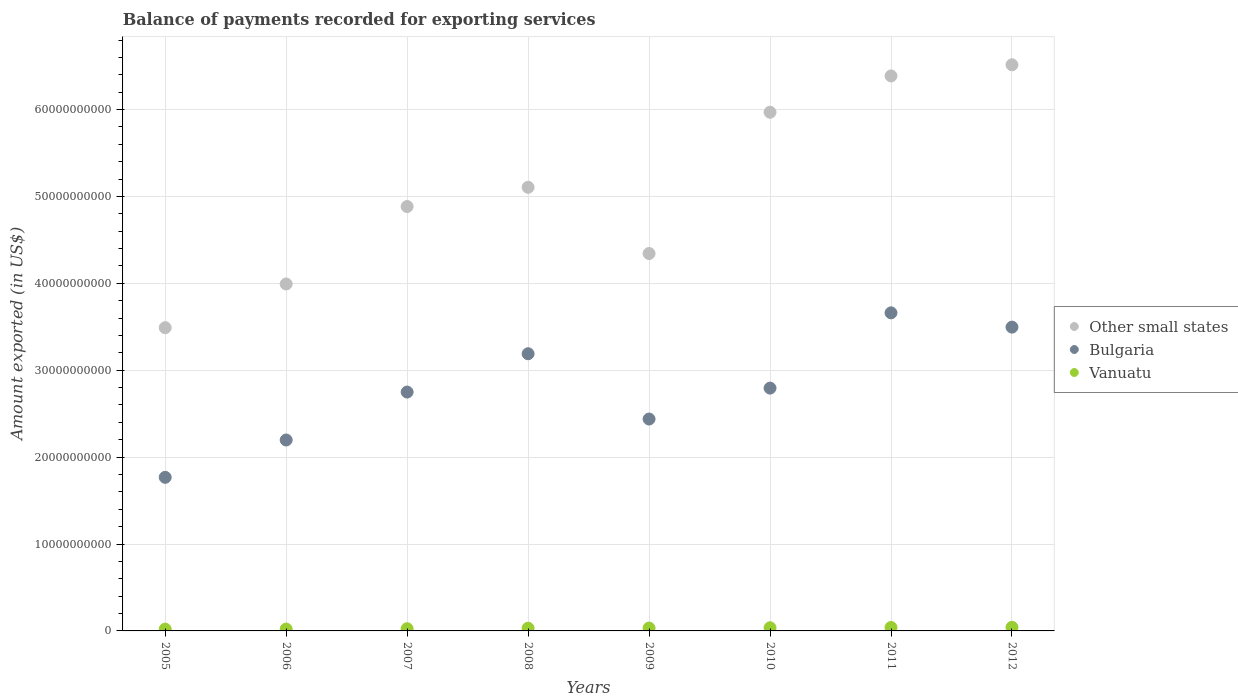How many different coloured dotlines are there?
Offer a terse response. 3. Is the number of dotlines equal to the number of legend labels?
Make the answer very short. Yes. What is the amount exported in Vanuatu in 2005?
Offer a terse response. 2.05e+08. Across all years, what is the maximum amount exported in Vanuatu?
Provide a succinct answer. 4.14e+08. Across all years, what is the minimum amount exported in Other small states?
Your answer should be compact. 3.49e+1. In which year was the amount exported in Other small states maximum?
Ensure brevity in your answer.  2012. What is the total amount exported in Vanuatu in the graph?
Ensure brevity in your answer.  2.50e+09. What is the difference between the amount exported in Other small states in 2007 and that in 2011?
Keep it short and to the point. -1.50e+1. What is the difference between the amount exported in Vanuatu in 2009 and the amount exported in Bulgaria in 2008?
Provide a short and direct response. -3.16e+1. What is the average amount exported in Other small states per year?
Provide a short and direct response. 5.09e+1. In the year 2009, what is the difference between the amount exported in Vanuatu and amount exported in Other small states?
Offer a very short reply. -4.31e+1. What is the ratio of the amount exported in Vanuatu in 2008 to that in 2011?
Ensure brevity in your answer.  0.79. Is the difference between the amount exported in Vanuatu in 2009 and 2011 greater than the difference between the amount exported in Other small states in 2009 and 2011?
Make the answer very short. Yes. What is the difference between the highest and the second highest amount exported in Bulgaria?
Ensure brevity in your answer.  1.65e+09. What is the difference between the highest and the lowest amount exported in Vanuatu?
Give a very brief answer. 2.09e+08. Is it the case that in every year, the sum of the amount exported in Vanuatu and amount exported in Other small states  is greater than the amount exported in Bulgaria?
Provide a short and direct response. Yes. Is the amount exported in Vanuatu strictly less than the amount exported in Other small states over the years?
Your answer should be compact. Yes. How many years are there in the graph?
Give a very brief answer. 8. Does the graph contain any zero values?
Offer a very short reply. No. Where does the legend appear in the graph?
Offer a very short reply. Center right. How many legend labels are there?
Your response must be concise. 3. What is the title of the graph?
Keep it short and to the point. Balance of payments recorded for exporting services. Does "Fiji" appear as one of the legend labels in the graph?
Your answer should be compact. No. What is the label or title of the X-axis?
Your answer should be very brief. Years. What is the label or title of the Y-axis?
Ensure brevity in your answer.  Amount exported (in US$). What is the Amount exported (in US$) in Other small states in 2005?
Keep it short and to the point. 3.49e+1. What is the Amount exported (in US$) of Bulgaria in 2005?
Provide a succinct answer. 1.77e+1. What is the Amount exported (in US$) in Vanuatu in 2005?
Provide a succinct answer. 2.05e+08. What is the Amount exported (in US$) of Other small states in 2006?
Provide a short and direct response. 3.99e+1. What is the Amount exported (in US$) in Bulgaria in 2006?
Keep it short and to the point. 2.20e+1. What is the Amount exported (in US$) in Vanuatu in 2006?
Give a very brief answer. 2.15e+08. What is the Amount exported (in US$) in Other small states in 2007?
Make the answer very short. 4.88e+1. What is the Amount exported (in US$) of Bulgaria in 2007?
Provide a succinct answer. 2.75e+1. What is the Amount exported (in US$) of Vanuatu in 2007?
Your response must be concise. 2.56e+08. What is the Amount exported (in US$) in Other small states in 2008?
Ensure brevity in your answer.  5.11e+1. What is the Amount exported (in US$) of Bulgaria in 2008?
Your answer should be very brief. 3.19e+1. What is the Amount exported (in US$) in Vanuatu in 2008?
Ensure brevity in your answer.  3.14e+08. What is the Amount exported (in US$) in Other small states in 2009?
Keep it short and to the point. 4.34e+1. What is the Amount exported (in US$) of Bulgaria in 2009?
Keep it short and to the point. 2.44e+1. What is the Amount exported (in US$) in Vanuatu in 2009?
Offer a very short reply. 3.31e+08. What is the Amount exported (in US$) in Other small states in 2010?
Offer a very short reply. 5.97e+1. What is the Amount exported (in US$) in Bulgaria in 2010?
Offer a terse response. 2.79e+1. What is the Amount exported (in US$) of Vanuatu in 2010?
Offer a terse response. 3.65e+08. What is the Amount exported (in US$) of Other small states in 2011?
Your response must be concise. 6.39e+1. What is the Amount exported (in US$) of Bulgaria in 2011?
Provide a short and direct response. 3.66e+1. What is the Amount exported (in US$) of Vanuatu in 2011?
Give a very brief answer. 3.96e+08. What is the Amount exported (in US$) of Other small states in 2012?
Provide a short and direct response. 6.52e+1. What is the Amount exported (in US$) of Bulgaria in 2012?
Ensure brevity in your answer.  3.50e+1. What is the Amount exported (in US$) in Vanuatu in 2012?
Offer a very short reply. 4.14e+08. Across all years, what is the maximum Amount exported (in US$) in Other small states?
Offer a terse response. 6.52e+1. Across all years, what is the maximum Amount exported (in US$) of Bulgaria?
Your response must be concise. 3.66e+1. Across all years, what is the maximum Amount exported (in US$) of Vanuatu?
Provide a succinct answer. 4.14e+08. Across all years, what is the minimum Amount exported (in US$) in Other small states?
Your response must be concise. 3.49e+1. Across all years, what is the minimum Amount exported (in US$) in Bulgaria?
Your answer should be compact. 1.77e+1. Across all years, what is the minimum Amount exported (in US$) in Vanuatu?
Give a very brief answer. 2.05e+08. What is the total Amount exported (in US$) of Other small states in the graph?
Offer a very short reply. 4.07e+11. What is the total Amount exported (in US$) in Bulgaria in the graph?
Your answer should be compact. 2.23e+11. What is the total Amount exported (in US$) in Vanuatu in the graph?
Keep it short and to the point. 2.50e+09. What is the difference between the Amount exported (in US$) in Other small states in 2005 and that in 2006?
Ensure brevity in your answer.  -5.03e+09. What is the difference between the Amount exported (in US$) of Bulgaria in 2005 and that in 2006?
Offer a terse response. -4.30e+09. What is the difference between the Amount exported (in US$) of Vanuatu in 2005 and that in 2006?
Give a very brief answer. -1.07e+07. What is the difference between the Amount exported (in US$) in Other small states in 2005 and that in 2007?
Make the answer very short. -1.39e+1. What is the difference between the Amount exported (in US$) of Bulgaria in 2005 and that in 2007?
Provide a short and direct response. -9.81e+09. What is the difference between the Amount exported (in US$) in Vanuatu in 2005 and that in 2007?
Keep it short and to the point. -5.11e+07. What is the difference between the Amount exported (in US$) of Other small states in 2005 and that in 2008?
Your answer should be compact. -1.62e+1. What is the difference between the Amount exported (in US$) in Bulgaria in 2005 and that in 2008?
Your response must be concise. -1.42e+1. What is the difference between the Amount exported (in US$) in Vanuatu in 2005 and that in 2008?
Your answer should be compact. -1.09e+08. What is the difference between the Amount exported (in US$) of Other small states in 2005 and that in 2009?
Your answer should be compact. -8.53e+09. What is the difference between the Amount exported (in US$) of Bulgaria in 2005 and that in 2009?
Provide a short and direct response. -6.71e+09. What is the difference between the Amount exported (in US$) of Vanuatu in 2005 and that in 2009?
Your response must be concise. -1.26e+08. What is the difference between the Amount exported (in US$) in Other small states in 2005 and that in 2010?
Your answer should be compact. -2.48e+1. What is the difference between the Amount exported (in US$) of Bulgaria in 2005 and that in 2010?
Make the answer very short. -1.03e+1. What is the difference between the Amount exported (in US$) in Vanuatu in 2005 and that in 2010?
Give a very brief answer. -1.61e+08. What is the difference between the Amount exported (in US$) of Other small states in 2005 and that in 2011?
Your answer should be very brief. -2.90e+1. What is the difference between the Amount exported (in US$) in Bulgaria in 2005 and that in 2011?
Give a very brief answer. -1.89e+1. What is the difference between the Amount exported (in US$) in Vanuatu in 2005 and that in 2011?
Provide a succinct answer. -1.91e+08. What is the difference between the Amount exported (in US$) of Other small states in 2005 and that in 2012?
Offer a terse response. -3.03e+1. What is the difference between the Amount exported (in US$) of Bulgaria in 2005 and that in 2012?
Provide a succinct answer. -1.73e+1. What is the difference between the Amount exported (in US$) of Vanuatu in 2005 and that in 2012?
Your response must be concise. -2.09e+08. What is the difference between the Amount exported (in US$) in Other small states in 2006 and that in 2007?
Make the answer very short. -8.91e+09. What is the difference between the Amount exported (in US$) in Bulgaria in 2006 and that in 2007?
Give a very brief answer. -5.52e+09. What is the difference between the Amount exported (in US$) in Vanuatu in 2006 and that in 2007?
Offer a very short reply. -4.04e+07. What is the difference between the Amount exported (in US$) in Other small states in 2006 and that in 2008?
Ensure brevity in your answer.  -1.11e+1. What is the difference between the Amount exported (in US$) of Bulgaria in 2006 and that in 2008?
Give a very brief answer. -9.92e+09. What is the difference between the Amount exported (in US$) in Vanuatu in 2006 and that in 2008?
Offer a terse response. -9.83e+07. What is the difference between the Amount exported (in US$) of Other small states in 2006 and that in 2009?
Your answer should be very brief. -3.51e+09. What is the difference between the Amount exported (in US$) in Bulgaria in 2006 and that in 2009?
Your answer should be compact. -2.41e+09. What is the difference between the Amount exported (in US$) of Vanuatu in 2006 and that in 2009?
Offer a very short reply. -1.16e+08. What is the difference between the Amount exported (in US$) in Other small states in 2006 and that in 2010?
Give a very brief answer. -1.98e+1. What is the difference between the Amount exported (in US$) in Bulgaria in 2006 and that in 2010?
Offer a very short reply. -5.97e+09. What is the difference between the Amount exported (in US$) of Vanuatu in 2006 and that in 2010?
Keep it short and to the point. -1.50e+08. What is the difference between the Amount exported (in US$) in Other small states in 2006 and that in 2011?
Your response must be concise. -2.39e+1. What is the difference between the Amount exported (in US$) in Bulgaria in 2006 and that in 2011?
Give a very brief answer. -1.46e+1. What is the difference between the Amount exported (in US$) in Vanuatu in 2006 and that in 2011?
Give a very brief answer. -1.80e+08. What is the difference between the Amount exported (in US$) in Other small states in 2006 and that in 2012?
Keep it short and to the point. -2.52e+1. What is the difference between the Amount exported (in US$) in Bulgaria in 2006 and that in 2012?
Offer a terse response. -1.30e+1. What is the difference between the Amount exported (in US$) in Vanuatu in 2006 and that in 2012?
Make the answer very short. -1.98e+08. What is the difference between the Amount exported (in US$) of Other small states in 2007 and that in 2008?
Provide a succinct answer. -2.21e+09. What is the difference between the Amount exported (in US$) of Bulgaria in 2007 and that in 2008?
Provide a succinct answer. -4.41e+09. What is the difference between the Amount exported (in US$) of Vanuatu in 2007 and that in 2008?
Keep it short and to the point. -5.79e+07. What is the difference between the Amount exported (in US$) of Other small states in 2007 and that in 2009?
Your response must be concise. 5.41e+09. What is the difference between the Amount exported (in US$) of Bulgaria in 2007 and that in 2009?
Make the answer very short. 3.10e+09. What is the difference between the Amount exported (in US$) of Vanuatu in 2007 and that in 2009?
Offer a very short reply. -7.52e+07. What is the difference between the Amount exported (in US$) of Other small states in 2007 and that in 2010?
Offer a terse response. -1.09e+1. What is the difference between the Amount exported (in US$) of Bulgaria in 2007 and that in 2010?
Give a very brief answer. -4.56e+08. What is the difference between the Amount exported (in US$) of Vanuatu in 2007 and that in 2010?
Your answer should be compact. -1.10e+08. What is the difference between the Amount exported (in US$) in Other small states in 2007 and that in 2011?
Your response must be concise. -1.50e+1. What is the difference between the Amount exported (in US$) of Bulgaria in 2007 and that in 2011?
Your answer should be compact. -9.12e+09. What is the difference between the Amount exported (in US$) in Vanuatu in 2007 and that in 2011?
Make the answer very short. -1.40e+08. What is the difference between the Amount exported (in US$) of Other small states in 2007 and that in 2012?
Your answer should be very brief. -1.63e+1. What is the difference between the Amount exported (in US$) of Bulgaria in 2007 and that in 2012?
Offer a very short reply. -7.47e+09. What is the difference between the Amount exported (in US$) of Vanuatu in 2007 and that in 2012?
Keep it short and to the point. -1.58e+08. What is the difference between the Amount exported (in US$) of Other small states in 2008 and that in 2009?
Your answer should be very brief. 7.62e+09. What is the difference between the Amount exported (in US$) of Bulgaria in 2008 and that in 2009?
Your response must be concise. 7.51e+09. What is the difference between the Amount exported (in US$) of Vanuatu in 2008 and that in 2009?
Your answer should be compact. -1.73e+07. What is the difference between the Amount exported (in US$) of Other small states in 2008 and that in 2010?
Provide a succinct answer. -8.64e+09. What is the difference between the Amount exported (in US$) in Bulgaria in 2008 and that in 2010?
Provide a short and direct response. 3.95e+09. What is the difference between the Amount exported (in US$) in Vanuatu in 2008 and that in 2010?
Give a very brief answer. -5.18e+07. What is the difference between the Amount exported (in US$) in Other small states in 2008 and that in 2011?
Your response must be concise. -1.28e+1. What is the difference between the Amount exported (in US$) in Bulgaria in 2008 and that in 2011?
Make the answer very short. -4.71e+09. What is the difference between the Amount exported (in US$) in Vanuatu in 2008 and that in 2011?
Provide a succinct answer. -8.20e+07. What is the difference between the Amount exported (in US$) of Other small states in 2008 and that in 2012?
Your response must be concise. -1.41e+1. What is the difference between the Amount exported (in US$) of Bulgaria in 2008 and that in 2012?
Your answer should be compact. -3.06e+09. What is the difference between the Amount exported (in US$) in Vanuatu in 2008 and that in 2012?
Offer a very short reply. -1.00e+08. What is the difference between the Amount exported (in US$) in Other small states in 2009 and that in 2010?
Keep it short and to the point. -1.63e+1. What is the difference between the Amount exported (in US$) in Bulgaria in 2009 and that in 2010?
Ensure brevity in your answer.  -3.56e+09. What is the difference between the Amount exported (in US$) in Vanuatu in 2009 and that in 2010?
Provide a succinct answer. -3.45e+07. What is the difference between the Amount exported (in US$) of Other small states in 2009 and that in 2011?
Offer a very short reply. -2.04e+1. What is the difference between the Amount exported (in US$) of Bulgaria in 2009 and that in 2011?
Your answer should be very brief. -1.22e+1. What is the difference between the Amount exported (in US$) in Vanuatu in 2009 and that in 2011?
Your response must be concise. -6.48e+07. What is the difference between the Amount exported (in US$) in Other small states in 2009 and that in 2012?
Provide a short and direct response. -2.17e+1. What is the difference between the Amount exported (in US$) of Bulgaria in 2009 and that in 2012?
Provide a succinct answer. -1.06e+1. What is the difference between the Amount exported (in US$) of Vanuatu in 2009 and that in 2012?
Keep it short and to the point. -8.28e+07. What is the difference between the Amount exported (in US$) of Other small states in 2010 and that in 2011?
Your response must be concise. -4.18e+09. What is the difference between the Amount exported (in US$) of Bulgaria in 2010 and that in 2011?
Offer a very short reply. -8.66e+09. What is the difference between the Amount exported (in US$) in Vanuatu in 2010 and that in 2011?
Offer a very short reply. -3.03e+07. What is the difference between the Amount exported (in US$) in Other small states in 2010 and that in 2012?
Provide a succinct answer. -5.46e+09. What is the difference between the Amount exported (in US$) of Bulgaria in 2010 and that in 2012?
Offer a very short reply. -7.02e+09. What is the difference between the Amount exported (in US$) in Vanuatu in 2010 and that in 2012?
Ensure brevity in your answer.  -4.83e+07. What is the difference between the Amount exported (in US$) of Other small states in 2011 and that in 2012?
Your answer should be very brief. -1.28e+09. What is the difference between the Amount exported (in US$) in Bulgaria in 2011 and that in 2012?
Provide a short and direct response. 1.65e+09. What is the difference between the Amount exported (in US$) of Vanuatu in 2011 and that in 2012?
Offer a very short reply. -1.80e+07. What is the difference between the Amount exported (in US$) in Other small states in 2005 and the Amount exported (in US$) in Bulgaria in 2006?
Your answer should be compact. 1.29e+1. What is the difference between the Amount exported (in US$) of Other small states in 2005 and the Amount exported (in US$) of Vanuatu in 2006?
Provide a succinct answer. 3.47e+1. What is the difference between the Amount exported (in US$) in Bulgaria in 2005 and the Amount exported (in US$) in Vanuatu in 2006?
Make the answer very short. 1.75e+1. What is the difference between the Amount exported (in US$) in Other small states in 2005 and the Amount exported (in US$) in Bulgaria in 2007?
Your response must be concise. 7.41e+09. What is the difference between the Amount exported (in US$) of Other small states in 2005 and the Amount exported (in US$) of Vanuatu in 2007?
Offer a terse response. 3.46e+1. What is the difference between the Amount exported (in US$) in Bulgaria in 2005 and the Amount exported (in US$) in Vanuatu in 2007?
Ensure brevity in your answer.  1.74e+1. What is the difference between the Amount exported (in US$) of Other small states in 2005 and the Amount exported (in US$) of Bulgaria in 2008?
Ensure brevity in your answer.  3.00e+09. What is the difference between the Amount exported (in US$) of Other small states in 2005 and the Amount exported (in US$) of Vanuatu in 2008?
Make the answer very short. 3.46e+1. What is the difference between the Amount exported (in US$) in Bulgaria in 2005 and the Amount exported (in US$) in Vanuatu in 2008?
Your response must be concise. 1.74e+1. What is the difference between the Amount exported (in US$) of Other small states in 2005 and the Amount exported (in US$) of Bulgaria in 2009?
Give a very brief answer. 1.05e+1. What is the difference between the Amount exported (in US$) in Other small states in 2005 and the Amount exported (in US$) in Vanuatu in 2009?
Give a very brief answer. 3.46e+1. What is the difference between the Amount exported (in US$) in Bulgaria in 2005 and the Amount exported (in US$) in Vanuatu in 2009?
Give a very brief answer. 1.73e+1. What is the difference between the Amount exported (in US$) in Other small states in 2005 and the Amount exported (in US$) in Bulgaria in 2010?
Make the answer very short. 6.95e+09. What is the difference between the Amount exported (in US$) of Other small states in 2005 and the Amount exported (in US$) of Vanuatu in 2010?
Provide a succinct answer. 3.45e+1. What is the difference between the Amount exported (in US$) in Bulgaria in 2005 and the Amount exported (in US$) in Vanuatu in 2010?
Provide a succinct answer. 1.73e+1. What is the difference between the Amount exported (in US$) in Other small states in 2005 and the Amount exported (in US$) in Bulgaria in 2011?
Keep it short and to the point. -1.71e+09. What is the difference between the Amount exported (in US$) in Other small states in 2005 and the Amount exported (in US$) in Vanuatu in 2011?
Provide a succinct answer. 3.45e+1. What is the difference between the Amount exported (in US$) in Bulgaria in 2005 and the Amount exported (in US$) in Vanuatu in 2011?
Offer a terse response. 1.73e+1. What is the difference between the Amount exported (in US$) of Other small states in 2005 and the Amount exported (in US$) of Bulgaria in 2012?
Your answer should be compact. -6.24e+07. What is the difference between the Amount exported (in US$) of Other small states in 2005 and the Amount exported (in US$) of Vanuatu in 2012?
Give a very brief answer. 3.45e+1. What is the difference between the Amount exported (in US$) in Bulgaria in 2005 and the Amount exported (in US$) in Vanuatu in 2012?
Your response must be concise. 1.73e+1. What is the difference between the Amount exported (in US$) in Other small states in 2006 and the Amount exported (in US$) in Bulgaria in 2007?
Your response must be concise. 1.24e+1. What is the difference between the Amount exported (in US$) in Other small states in 2006 and the Amount exported (in US$) in Vanuatu in 2007?
Make the answer very short. 3.97e+1. What is the difference between the Amount exported (in US$) in Bulgaria in 2006 and the Amount exported (in US$) in Vanuatu in 2007?
Provide a succinct answer. 2.17e+1. What is the difference between the Amount exported (in US$) of Other small states in 2006 and the Amount exported (in US$) of Bulgaria in 2008?
Provide a succinct answer. 8.03e+09. What is the difference between the Amount exported (in US$) in Other small states in 2006 and the Amount exported (in US$) in Vanuatu in 2008?
Keep it short and to the point. 3.96e+1. What is the difference between the Amount exported (in US$) in Bulgaria in 2006 and the Amount exported (in US$) in Vanuatu in 2008?
Keep it short and to the point. 2.17e+1. What is the difference between the Amount exported (in US$) in Other small states in 2006 and the Amount exported (in US$) in Bulgaria in 2009?
Give a very brief answer. 1.55e+1. What is the difference between the Amount exported (in US$) of Other small states in 2006 and the Amount exported (in US$) of Vanuatu in 2009?
Provide a short and direct response. 3.96e+1. What is the difference between the Amount exported (in US$) of Bulgaria in 2006 and the Amount exported (in US$) of Vanuatu in 2009?
Offer a very short reply. 2.16e+1. What is the difference between the Amount exported (in US$) in Other small states in 2006 and the Amount exported (in US$) in Bulgaria in 2010?
Make the answer very short. 1.20e+1. What is the difference between the Amount exported (in US$) of Other small states in 2006 and the Amount exported (in US$) of Vanuatu in 2010?
Keep it short and to the point. 3.96e+1. What is the difference between the Amount exported (in US$) in Bulgaria in 2006 and the Amount exported (in US$) in Vanuatu in 2010?
Provide a succinct answer. 2.16e+1. What is the difference between the Amount exported (in US$) of Other small states in 2006 and the Amount exported (in US$) of Bulgaria in 2011?
Give a very brief answer. 3.32e+09. What is the difference between the Amount exported (in US$) in Other small states in 2006 and the Amount exported (in US$) in Vanuatu in 2011?
Offer a terse response. 3.95e+1. What is the difference between the Amount exported (in US$) of Bulgaria in 2006 and the Amount exported (in US$) of Vanuatu in 2011?
Offer a very short reply. 2.16e+1. What is the difference between the Amount exported (in US$) of Other small states in 2006 and the Amount exported (in US$) of Bulgaria in 2012?
Give a very brief answer. 4.97e+09. What is the difference between the Amount exported (in US$) in Other small states in 2006 and the Amount exported (in US$) in Vanuatu in 2012?
Give a very brief answer. 3.95e+1. What is the difference between the Amount exported (in US$) in Bulgaria in 2006 and the Amount exported (in US$) in Vanuatu in 2012?
Provide a short and direct response. 2.16e+1. What is the difference between the Amount exported (in US$) of Other small states in 2007 and the Amount exported (in US$) of Bulgaria in 2008?
Your answer should be very brief. 1.69e+1. What is the difference between the Amount exported (in US$) in Other small states in 2007 and the Amount exported (in US$) in Vanuatu in 2008?
Your response must be concise. 4.85e+1. What is the difference between the Amount exported (in US$) in Bulgaria in 2007 and the Amount exported (in US$) in Vanuatu in 2008?
Your answer should be very brief. 2.72e+1. What is the difference between the Amount exported (in US$) in Other small states in 2007 and the Amount exported (in US$) in Bulgaria in 2009?
Provide a short and direct response. 2.45e+1. What is the difference between the Amount exported (in US$) of Other small states in 2007 and the Amount exported (in US$) of Vanuatu in 2009?
Your answer should be very brief. 4.85e+1. What is the difference between the Amount exported (in US$) in Bulgaria in 2007 and the Amount exported (in US$) in Vanuatu in 2009?
Give a very brief answer. 2.72e+1. What is the difference between the Amount exported (in US$) of Other small states in 2007 and the Amount exported (in US$) of Bulgaria in 2010?
Make the answer very short. 2.09e+1. What is the difference between the Amount exported (in US$) in Other small states in 2007 and the Amount exported (in US$) in Vanuatu in 2010?
Provide a succinct answer. 4.85e+1. What is the difference between the Amount exported (in US$) of Bulgaria in 2007 and the Amount exported (in US$) of Vanuatu in 2010?
Offer a terse response. 2.71e+1. What is the difference between the Amount exported (in US$) of Other small states in 2007 and the Amount exported (in US$) of Bulgaria in 2011?
Your answer should be very brief. 1.22e+1. What is the difference between the Amount exported (in US$) in Other small states in 2007 and the Amount exported (in US$) in Vanuatu in 2011?
Keep it short and to the point. 4.84e+1. What is the difference between the Amount exported (in US$) of Bulgaria in 2007 and the Amount exported (in US$) of Vanuatu in 2011?
Provide a short and direct response. 2.71e+1. What is the difference between the Amount exported (in US$) of Other small states in 2007 and the Amount exported (in US$) of Bulgaria in 2012?
Make the answer very short. 1.39e+1. What is the difference between the Amount exported (in US$) in Other small states in 2007 and the Amount exported (in US$) in Vanuatu in 2012?
Offer a very short reply. 4.84e+1. What is the difference between the Amount exported (in US$) of Bulgaria in 2007 and the Amount exported (in US$) of Vanuatu in 2012?
Provide a short and direct response. 2.71e+1. What is the difference between the Amount exported (in US$) of Other small states in 2008 and the Amount exported (in US$) of Bulgaria in 2009?
Your answer should be very brief. 2.67e+1. What is the difference between the Amount exported (in US$) in Other small states in 2008 and the Amount exported (in US$) in Vanuatu in 2009?
Offer a terse response. 5.07e+1. What is the difference between the Amount exported (in US$) of Bulgaria in 2008 and the Amount exported (in US$) of Vanuatu in 2009?
Your response must be concise. 3.16e+1. What is the difference between the Amount exported (in US$) of Other small states in 2008 and the Amount exported (in US$) of Bulgaria in 2010?
Your answer should be compact. 2.31e+1. What is the difference between the Amount exported (in US$) of Other small states in 2008 and the Amount exported (in US$) of Vanuatu in 2010?
Offer a terse response. 5.07e+1. What is the difference between the Amount exported (in US$) in Bulgaria in 2008 and the Amount exported (in US$) in Vanuatu in 2010?
Make the answer very short. 3.15e+1. What is the difference between the Amount exported (in US$) of Other small states in 2008 and the Amount exported (in US$) of Bulgaria in 2011?
Your answer should be compact. 1.44e+1. What is the difference between the Amount exported (in US$) of Other small states in 2008 and the Amount exported (in US$) of Vanuatu in 2011?
Keep it short and to the point. 5.07e+1. What is the difference between the Amount exported (in US$) in Bulgaria in 2008 and the Amount exported (in US$) in Vanuatu in 2011?
Give a very brief answer. 3.15e+1. What is the difference between the Amount exported (in US$) of Other small states in 2008 and the Amount exported (in US$) of Bulgaria in 2012?
Offer a terse response. 1.61e+1. What is the difference between the Amount exported (in US$) in Other small states in 2008 and the Amount exported (in US$) in Vanuatu in 2012?
Ensure brevity in your answer.  5.06e+1. What is the difference between the Amount exported (in US$) of Bulgaria in 2008 and the Amount exported (in US$) of Vanuatu in 2012?
Ensure brevity in your answer.  3.15e+1. What is the difference between the Amount exported (in US$) in Other small states in 2009 and the Amount exported (in US$) in Bulgaria in 2010?
Make the answer very short. 1.55e+1. What is the difference between the Amount exported (in US$) in Other small states in 2009 and the Amount exported (in US$) in Vanuatu in 2010?
Offer a very short reply. 4.31e+1. What is the difference between the Amount exported (in US$) of Bulgaria in 2009 and the Amount exported (in US$) of Vanuatu in 2010?
Keep it short and to the point. 2.40e+1. What is the difference between the Amount exported (in US$) of Other small states in 2009 and the Amount exported (in US$) of Bulgaria in 2011?
Provide a short and direct response. 6.83e+09. What is the difference between the Amount exported (in US$) in Other small states in 2009 and the Amount exported (in US$) in Vanuatu in 2011?
Ensure brevity in your answer.  4.30e+1. What is the difference between the Amount exported (in US$) in Bulgaria in 2009 and the Amount exported (in US$) in Vanuatu in 2011?
Make the answer very short. 2.40e+1. What is the difference between the Amount exported (in US$) in Other small states in 2009 and the Amount exported (in US$) in Bulgaria in 2012?
Make the answer very short. 8.47e+09. What is the difference between the Amount exported (in US$) of Other small states in 2009 and the Amount exported (in US$) of Vanuatu in 2012?
Offer a very short reply. 4.30e+1. What is the difference between the Amount exported (in US$) of Bulgaria in 2009 and the Amount exported (in US$) of Vanuatu in 2012?
Provide a short and direct response. 2.40e+1. What is the difference between the Amount exported (in US$) in Other small states in 2010 and the Amount exported (in US$) in Bulgaria in 2011?
Make the answer very short. 2.31e+1. What is the difference between the Amount exported (in US$) in Other small states in 2010 and the Amount exported (in US$) in Vanuatu in 2011?
Keep it short and to the point. 5.93e+1. What is the difference between the Amount exported (in US$) in Bulgaria in 2010 and the Amount exported (in US$) in Vanuatu in 2011?
Ensure brevity in your answer.  2.75e+1. What is the difference between the Amount exported (in US$) in Other small states in 2010 and the Amount exported (in US$) in Bulgaria in 2012?
Make the answer very short. 2.47e+1. What is the difference between the Amount exported (in US$) in Other small states in 2010 and the Amount exported (in US$) in Vanuatu in 2012?
Offer a terse response. 5.93e+1. What is the difference between the Amount exported (in US$) in Bulgaria in 2010 and the Amount exported (in US$) in Vanuatu in 2012?
Provide a succinct answer. 2.75e+1. What is the difference between the Amount exported (in US$) in Other small states in 2011 and the Amount exported (in US$) in Bulgaria in 2012?
Keep it short and to the point. 2.89e+1. What is the difference between the Amount exported (in US$) of Other small states in 2011 and the Amount exported (in US$) of Vanuatu in 2012?
Make the answer very short. 6.35e+1. What is the difference between the Amount exported (in US$) of Bulgaria in 2011 and the Amount exported (in US$) of Vanuatu in 2012?
Provide a short and direct response. 3.62e+1. What is the average Amount exported (in US$) in Other small states per year?
Make the answer very short. 5.09e+1. What is the average Amount exported (in US$) in Bulgaria per year?
Your answer should be compact. 2.79e+1. What is the average Amount exported (in US$) in Vanuatu per year?
Offer a very short reply. 3.12e+08. In the year 2005, what is the difference between the Amount exported (in US$) of Other small states and Amount exported (in US$) of Bulgaria?
Give a very brief answer. 1.72e+1. In the year 2005, what is the difference between the Amount exported (in US$) in Other small states and Amount exported (in US$) in Vanuatu?
Keep it short and to the point. 3.47e+1. In the year 2005, what is the difference between the Amount exported (in US$) of Bulgaria and Amount exported (in US$) of Vanuatu?
Your answer should be very brief. 1.75e+1. In the year 2006, what is the difference between the Amount exported (in US$) of Other small states and Amount exported (in US$) of Bulgaria?
Keep it short and to the point. 1.80e+1. In the year 2006, what is the difference between the Amount exported (in US$) in Other small states and Amount exported (in US$) in Vanuatu?
Make the answer very short. 3.97e+1. In the year 2006, what is the difference between the Amount exported (in US$) in Bulgaria and Amount exported (in US$) in Vanuatu?
Provide a short and direct response. 2.18e+1. In the year 2007, what is the difference between the Amount exported (in US$) in Other small states and Amount exported (in US$) in Bulgaria?
Provide a succinct answer. 2.14e+1. In the year 2007, what is the difference between the Amount exported (in US$) of Other small states and Amount exported (in US$) of Vanuatu?
Give a very brief answer. 4.86e+1. In the year 2007, what is the difference between the Amount exported (in US$) of Bulgaria and Amount exported (in US$) of Vanuatu?
Ensure brevity in your answer.  2.72e+1. In the year 2008, what is the difference between the Amount exported (in US$) of Other small states and Amount exported (in US$) of Bulgaria?
Provide a succinct answer. 1.92e+1. In the year 2008, what is the difference between the Amount exported (in US$) in Other small states and Amount exported (in US$) in Vanuatu?
Your answer should be very brief. 5.07e+1. In the year 2008, what is the difference between the Amount exported (in US$) in Bulgaria and Amount exported (in US$) in Vanuatu?
Provide a short and direct response. 3.16e+1. In the year 2009, what is the difference between the Amount exported (in US$) of Other small states and Amount exported (in US$) of Bulgaria?
Offer a terse response. 1.90e+1. In the year 2009, what is the difference between the Amount exported (in US$) in Other small states and Amount exported (in US$) in Vanuatu?
Your answer should be compact. 4.31e+1. In the year 2009, what is the difference between the Amount exported (in US$) of Bulgaria and Amount exported (in US$) of Vanuatu?
Offer a terse response. 2.41e+1. In the year 2010, what is the difference between the Amount exported (in US$) of Other small states and Amount exported (in US$) of Bulgaria?
Offer a terse response. 3.17e+1. In the year 2010, what is the difference between the Amount exported (in US$) of Other small states and Amount exported (in US$) of Vanuatu?
Offer a very short reply. 5.93e+1. In the year 2010, what is the difference between the Amount exported (in US$) of Bulgaria and Amount exported (in US$) of Vanuatu?
Your response must be concise. 2.76e+1. In the year 2011, what is the difference between the Amount exported (in US$) of Other small states and Amount exported (in US$) of Bulgaria?
Offer a very short reply. 2.73e+1. In the year 2011, what is the difference between the Amount exported (in US$) of Other small states and Amount exported (in US$) of Vanuatu?
Provide a succinct answer. 6.35e+1. In the year 2011, what is the difference between the Amount exported (in US$) in Bulgaria and Amount exported (in US$) in Vanuatu?
Your answer should be very brief. 3.62e+1. In the year 2012, what is the difference between the Amount exported (in US$) in Other small states and Amount exported (in US$) in Bulgaria?
Offer a very short reply. 3.02e+1. In the year 2012, what is the difference between the Amount exported (in US$) in Other small states and Amount exported (in US$) in Vanuatu?
Keep it short and to the point. 6.47e+1. In the year 2012, what is the difference between the Amount exported (in US$) of Bulgaria and Amount exported (in US$) of Vanuatu?
Give a very brief answer. 3.45e+1. What is the ratio of the Amount exported (in US$) in Other small states in 2005 to that in 2006?
Keep it short and to the point. 0.87. What is the ratio of the Amount exported (in US$) in Bulgaria in 2005 to that in 2006?
Give a very brief answer. 0.8. What is the ratio of the Amount exported (in US$) in Vanuatu in 2005 to that in 2006?
Offer a terse response. 0.95. What is the ratio of the Amount exported (in US$) in Other small states in 2005 to that in 2007?
Your answer should be very brief. 0.71. What is the ratio of the Amount exported (in US$) of Bulgaria in 2005 to that in 2007?
Your answer should be very brief. 0.64. What is the ratio of the Amount exported (in US$) in Other small states in 2005 to that in 2008?
Provide a succinct answer. 0.68. What is the ratio of the Amount exported (in US$) of Bulgaria in 2005 to that in 2008?
Provide a short and direct response. 0.55. What is the ratio of the Amount exported (in US$) in Vanuatu in 2005 to that in 2008?
Your response must be concise. 0.65. What is the ratio of the Amount exported (in US$) of Other small states in 2005 to that in 2009?
Provide a succinct answer. 0.8. What is the ratio of the Amount exported (in US$) in Bulgaria in 2005 to that in 2009?
Provide a short and direct response. 0.72. What is the ratio of the Amount exported (in US$) of Vanuatu in 2005 to that in 2009?
Provide a short and direct response. 0.62. What is the ratio of the Amount exported (in US$) in Other small states in 2005 to that in 2010?
Offer a terse response. 0.58. What is the ratio of the Amount exported (in US$) in Bulgaria in 2005 to that in 2010?
Keep it short and to the point. 0.63. What is the ratio of the Amount exported (in US$) in Vanuatu in 2005 to that in 2010?
Provide a short and direct response. 0.56. What is the ratio of the Amount exported (in US$) of Other small states in 2005 to that in 2011?
Your answer should be very brief. 0.55. What is the ratio of the Amount exported (in US$) in Bulgaria in 2005 to that in 2011?
Give a very brief answer. 0.48. What is the ratio of the Amount exported (in US$) of Vanuatu in 2005 to that in 2011?
Your response must be concise. 0.52. What is the ratio of the Amount exported (in US$) of Other small states in 2005 to that in 2012?
Offer a very short reply. 0.54. What is the ratio of the Amount exported (in US$) of Bulgaria in 2005 to that in 2012?
Provide a succinct answer. 0.51. What is the ratio of the Amount exported (in US$) of Vanuatu in 2005 to that in 2012?
Make the answer very short. 0.49. What is the ratio of the Amount exported (in US$) in Other small states in 2006 to that in 2007?
Keep it short and to the point. 0.82. What is the ratio of the Amount exported (in US$) in Bulgaria in 2006 to that in 2007?
Your answer should be very brief. 0.8. What is the ratio of the Amount exported (in US$) of Vanuatu in 2006 to that in 2007?
Keep it short and to the point. 0.84. What is the ratio of the Amount exported (in US$) of Other small states in 2006 to that in 2008?
Your answer should be very brief. 0.78. What is the ratio of the Amount exported (in US$) of Bulgaria in 2006 to that in 2008?
Offer a very short reply. 0.69. What is the ratio of the Amount exported (in US$) of Vanuatu in 2006 to that in 2008?
Offer a very short reply. 0.69. What is the ratio of the Amount exported (in US$) of Other small states in 2006 to that in 2009?
Your answer should be very brief. 0.92. What is the ratio of the Amount exported (in US$) in Bulgaria in 2006 to that in 2009?
Make the answer very short. 0.9. What is the ratio of the Amount exported (in US$) in Vanuatu in 2006 to that in 2009?
Provide a succinct answer. 0.65. What is the ratio of the Amount exported (in US$) in Other small states in 2006 to that in 2010?
Offer a terse response. 0.67. What is the ratio of the Amount exported (in US$) in Bulgaria in 2006 to that in 2010?
Keep it short and to the point. 0.79. What is the ratio of the Amount exported (in US$) of Vanuatu in 2006 to that in 2010?
Keep it short and to the point. 0.59. What is the ratio of the Amount exported (in US$) of Other small states in 2006 to that in 2011?
Keep it short and to the point. 0.63. What is the ratio of the Amount exported (in US$) of Bulgaria in 2006 to that in 2011?
Ensure brevity in your answer.  0.6. What is the ratio of the Amount exported (in US$) in Vanuatu in 2006 to that in 2011?
Your answer should be very brief. 0.54. What is the ratio of the Amount exported (in US$) in Other small states in 2006 to that in 2012?
Your answer should be compact. 0.61. What is the ratio of the Amount exported (in US$) of Bulgaria in 2006 to that in 2012?
Provide a short and direct response. 0.63. What is the ratio of the Amount exported (in US$) in Vanuatu in 2006 to that in 2012?
Your response must be concise. 0.52. What is the ratio of the Amount exported (in US$) in Other small states in 2007 to that in 2008?
Ensure brevity in your answer.  0.96. What is the ratio of the Amount exported (in US$) in Bulgaria in 2007 to that in 2008?
Ensure brevity in your answer.  0.86. What is the ratio of the Amount exported (in US$) in Vanuatu in 2007 to that in 2008?
Your answer should be very brief. 0.82. What is the ratio of the Amount exported (in US$) of Other small states in 2007 to that in 2009?
Your answer should be compact. 1.12. What is the ratio of the Amount exported (in US$) of Bulgaria in 2007 to that in 2009?
Provide a short and direct response. 1.13. What is the ratio of the Amount exported (in US$) of Vanuatu in 2007 to that in 2009?
Keep it short and to the point. 0.77. What is the ratio of the Amount exported (in US$) of Other small states in 2007 to that in 2010?
Offer a very short reply. 0.82. What is the ratio of the Amount exported (in US$) in Bulgaria in 2007 to that in 2010?
Provide a succinct answer. 0.98. What is the ratio of the Amount exported (in US$) in Vanuatu in 2007 to that in 2010?
Your answer should be very brief. 0.7. What is the ratio of the Amount exported (in US$) of Other small states in 2007 to that in 2011?
Keep it short and to the point. 0.76. What is the ratio of the Amount exported (in US$) of Bulgaria in 2007 to that in 2011?
Your answer should be very brief. 0.75. What is the ratio of the Amount exported (in US$) in Vanuatu in 2007 to that in 2011?
Offer a terse response. 0.65. What is the ratio of the Amount exported (in US$) of Other small states in 2007 to that in 2012?
Give a very brief answer. 0.75. What is the ratio of the Amount exported (in US$) in Bulgaria in 2007 to that in 2012?
Your response must be concise. 0.79. What is the ratio of the Amount exported (in US$) in Vanuatu in 2007 to that in 2012?
Give a very brief answer. 0.62. What is the ratio of the Amount exported (in US$) of Other small states in 2008 to that in 2009?
Offer a terse response. 1.18. What is the ratio of the Amount exported (in US$) of Bulgaria in 2008 to that in 2009?
Offer a very short reply. 1.31. What is the ratio of the Amount exported (in US$) of Vanuatu in 2008 to that in 2009?
Keep it short and to the point. 0.95. What is the ratio of the Amount exported (in US$) of Other small states in 2008 to that in 2010?
Provide a short and direct response. 0.86. What is the ratio of the Amount exported (in US$) of Bulgaria in 2008 to that in 2010?
Provide a short and direct response. 1.14. What is the ratio of the Amount exported (in US$) of Vanuatu in 2008 to that in 2010?
Provide a short and direct response. 0.86. What is the ratio of the Amount exported (in US$) of Other small states in 2008 to that in 2011?
Provide a short and direct response. 0.8. What is the ratio of the Amount exported (in US$) in Bulgaria in 2008 to that in 2011?
Offer a very short reply. 0.87. What is the ratio of the Amount exported (in US$) of Vanuatu in 2008 to that in 2011?
Offer a terse response. 0.79. What is the ratio of the Amount exported (in US$) in Other small states in 2008 to that in 2012?
Offer a terse response. 0.78. What is the ratio of the Amount exported (in US$) of Bulgaria in 2008 to that in 2012?
Offer a terse response. 0.91. What is the ratio of the Amount exported (in US$) of Vanuatu in 2008 to that in 2012?
Offer a very short reply. 0.76. What is the ratio of the Amount exported (in US$) of Other small states in 2009 to that in 2010?
Your answer should be very brief. 0.73. What is the ratio of the Amount exported (in US$) in Bulgaria in 2009 to that in 2010?
Make the answer very short. 0.87. What is the ratio of the Amount exported (in US$) of Vanuatu in 2009 to that in 2010?
Your response must be concise. 0.91. What is the ratio of the Amount exported (in US$) of Other small states in 2009 to that in 2011?
Your response must be concise. 0.68. What is the ratio of the Amount exported (in US$) in Bulgaria in 2009 to that in 2011?
Your answer should be compact. 0.67. What is the ratio of the Amount exported (in US$) of Vanuatu in 2009 to that in 2011?
Provide a succinct answer. 0.84. What is the ratio of the Amount exported (in US$) of Other small states in 2009 to that in 2012?
Offer a terse response. 0.67. What is the ratio of the Amount exported (in US$) of Bulgaria in 2009 to that in 2012?
Give a very brief answer. 0.7. What is the ratio of the Amount exported (in US$) in Vanuatu in 2009 to that in 2012?
Provide a succinct answer. 0.8. What is the ratio of the Amount exported (in US$) of Other small states in 2010 to that in 2011?
Give a very brief answer. 0.93. What is the ratio of the Amount exported (in US$) of Bulgaria in 2010 to that in 2011?
Offer a very short reply. 0.76. What is the ratio of the Amount exported (in US$) in Vanuatu in 2010 to that in 2011?
Provide a succinct answer. 0.92. What is the ratio of the Amount exported (in US$) of Other small states in 2010 to that in 2012?
Provide a succinct answer. 0.92. What is the ratio of the Amount exported (in US$) in Bulgaria in 2010 to that in 2012?
Your answer should be very brief. 0.8. What is the ratio of the Amount exported (in US$) of Vanuatu in 2010 to that in 2012?
Make the answer very short. 0.88. What is the ratio of the Amount exported (in US$) of Other small states in 2011 to that in 2012?
Provide a short and direct response. 0.98. What is the ratio of the Amount exported (in US$) of Bulgaria in 2011 to that in 2012?
Provide a succinct answer. 1.05. What is the ratio of the Amount exported (in US$) in Vanuatu in 2011 to that in 2012?
Your answer should be compact. 0.96. What is the difference between the highest and the second highest Amount exported (in US$) in Other small states?
Make the answer very short. 1.28e+09. What is the difference between the highest and the second highest Amount exported (in US$) in Bulgaria?
Your answer should be very brief. 1.65e+09. What is the difference between the highest and the second highest Amount exported (in US$) in Vanuatu?
Ensure brevity in your answer.  1.80e+07. What is the difference between the highest and the lowest Amount exported (in US$) in Other small states?
Keep it short and to the point. 3.03e+1. What is the difference between the highest and the lowest Amount exported (in US$) in Bulgaria?
Ensure brevity in your answer.  1.89e+1. What is the difference between the highest and the lowest Amount exported (in US$) in Vanuatu?
Provide a short and direct response. 2.09e+08. 